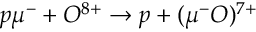Convert formula to latex. <formula><loc_0><loc_0><loc_500><loc_500>p \mu ^ { - } + O ^ { 8 + } \rightarrow p + ( \mu ^ { - } O ) ^ { 7 + }</formula> 